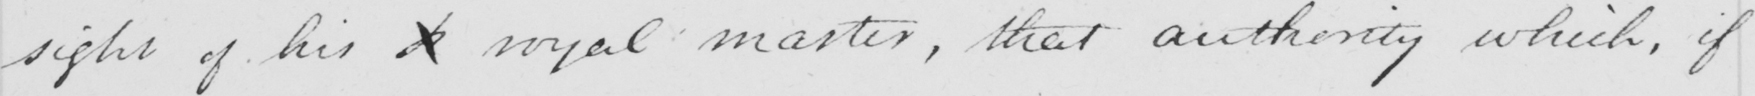What does this handwritten line say? sight of his  <gap/>  royal master , that authority which , if 